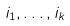<formula> <loc_0><loc_0><loc_500><loc_500>i _ { 1 } , \dots , i _ { k }</formula> 